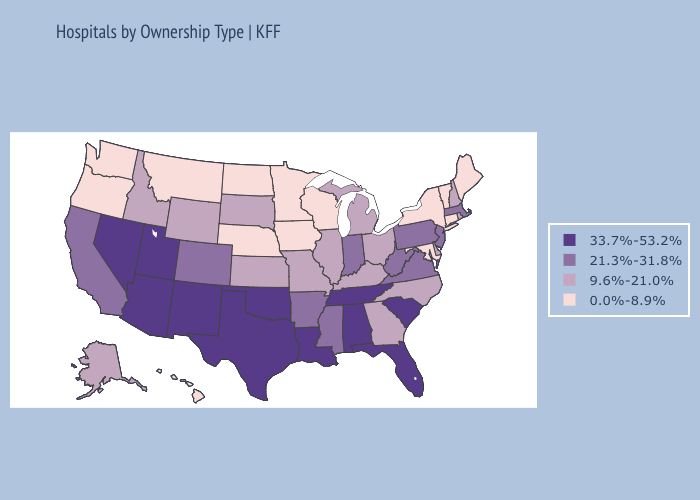Among the states that border Massachusetts , does New York have the highest value?
Quick response, please. No. What is the highest value in states that border California?
Short answer required. 33.7%-53.2%. Does Pennsylvania have the highest value in the Northeast?
Keep it brief. Yes. Name the states that have a value in the range 21.3%-31.8%?
Answer briefly. Arkansas, California, Colorado, Indiana, Massachusetts, Mississippi, New Jersey, Pennsylvania, Virginia, West Virginia. Name the states that have a value in the range 21.3%-31.8%?
Keep it brief. Arkansas, California, Colorado, Indiana, Massachusetts, Mississippi, New Jersey, Pennsylvania, Virginia, West Virginia. What is the lowest value in the South?
Quick response, please. 0.0%-8.9%. What is the highest value in the South ?
Write a very short answer. 33.7%-53.2%. Among the states that border Illinois , which have the highest value?
Short answer required. Indiana. Does Oklahoma have the highest value in the USA?
Write a very short answer. Yes. Among the states that border Delaware , does Maryland have the lowest value?
Write a very short answer. Yes. Does Illinois have a higher value than New Jersey?
Keep it brief. No. Does Michigan have the same value as Hawaii?
Be succinct. No. What is the highest value in the West ?
Concise answer only. 33.7%-53.2%. Does Colorado have a higher value than Wisconsin?
Give a very brief answer. Yes. What is the value of Wyoming?
Answer briefly. 9.6%-21.0%. 